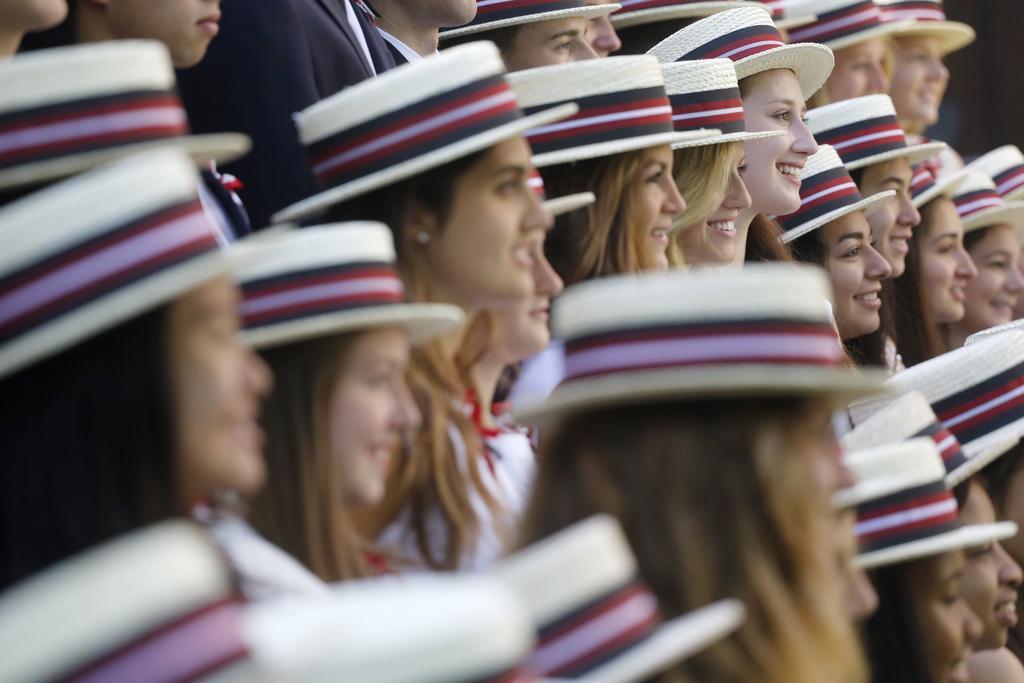Could you give a brief overview of what you see in this image? In the image there are many women standing with same color hat over their head and all the women are smiling. 